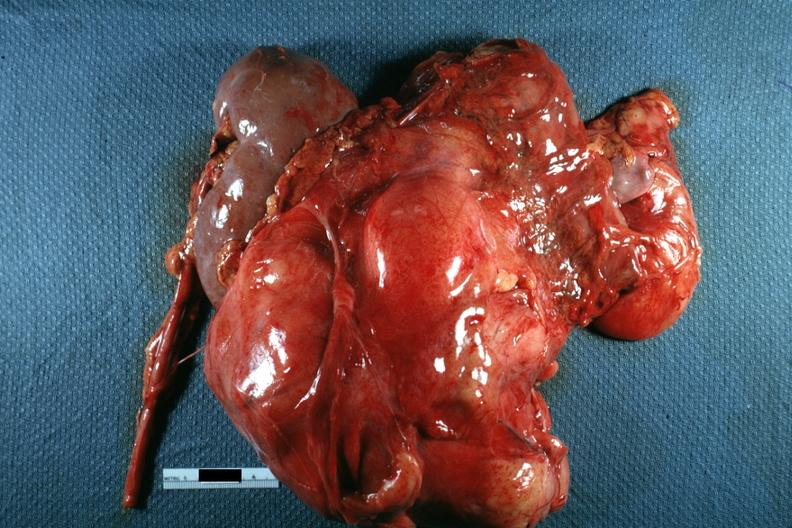does this image show nodular mass with kidney seen on one side photo of little use without showing cut surface?
Answer the question using a single word or phrase. Yes 